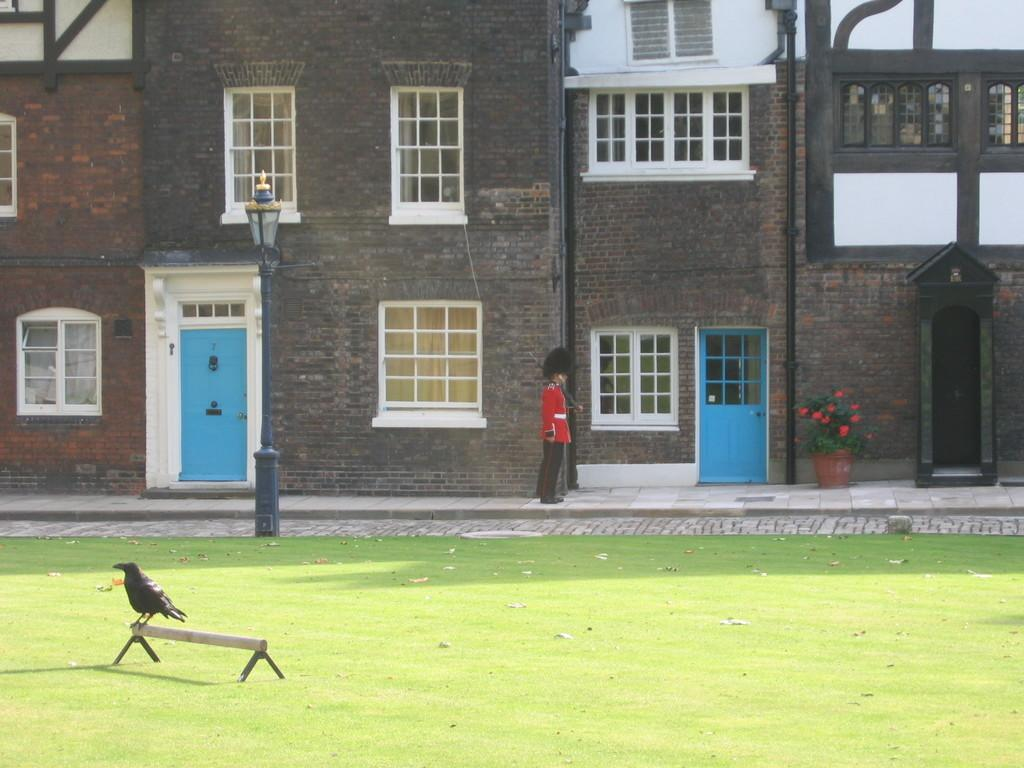What type of structures can be seen in the image? There are buildings in the image. What architectural features are visible on the buildings? There are windows and doors visible on the buildings. What other objects can be seen in the image? There are poles, a light, a flower pot with flowers, and a bird on a stand in the image. What is the title of the book that the bird is reading in the image? There is no book or reading activity depicted in the image; the bird is simply standing on a stand. 